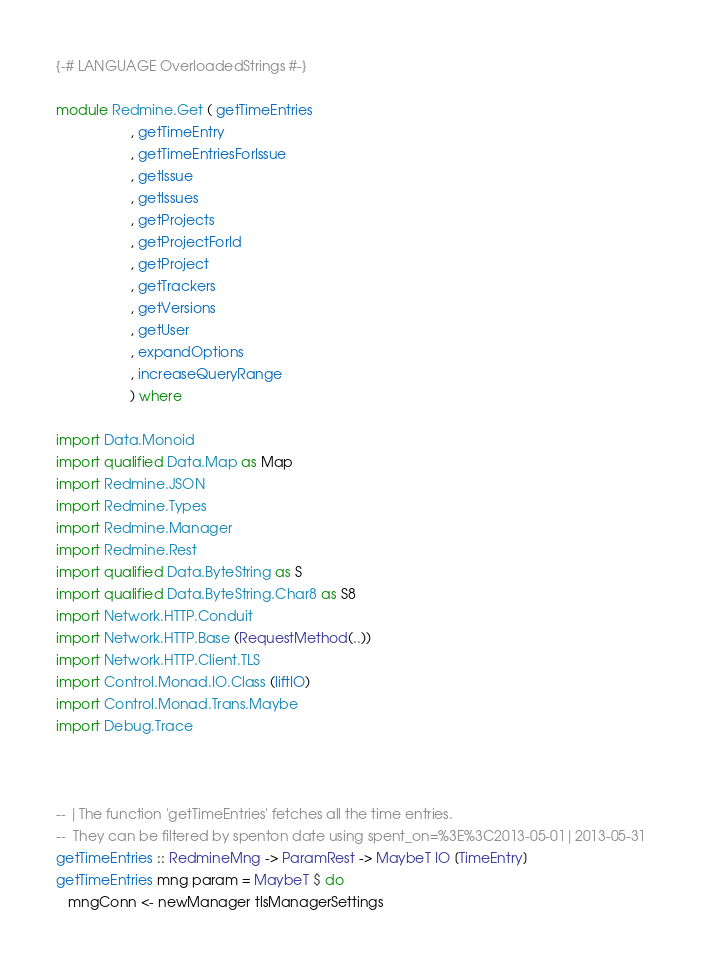<code> <loc_0><loc_0><loc_500><loc_500><_Haskell_>{-# LANGUAGE OverloadedStrings #-}

module Redmine.Get ( getTimeEntries
                   , getTimeEntry
                   , getTimeEntriesForIssue
                   , getIssue
                   , getIssues
                   , getProjects
                   , getProjectForId
                   , getProject
                   , getTrackers
                   , getVersions
                   , getUser
                   , expandOptions
                   , increaseQueryRange
                   ) where

import Data.Monoid
import qualified Data.Map as Map
import Redmine.JSON
import Redmine.Types
import Redmine.Manager
import Redmine.Rest
import qualified Data.ByteString as S
import qualified Data.ByteString.Char8 as S8
import Network.HTTP.Conduit
import Network.HTTP.Base (RequestMethod(..))
import Network.HTTP.Client.TLS
import Control.Monad.IO.Class (liftIO)
import Control.Monad.Trans.Maybe
import Debug.Trace



-- |The function 'getTimeEntries' fetches all the time entries.
--  They can be filtered by spenton date using spent_on=%3E%3C2013-05-01|2013-05-31
getTimeEntries :: RedmineMng -> ParamRest -> MaybeT IO [TimeEntry]
getTimeEntries mng param = MaybeT $ do
   mngConn <- newManager tlsManagerSettings</code> 